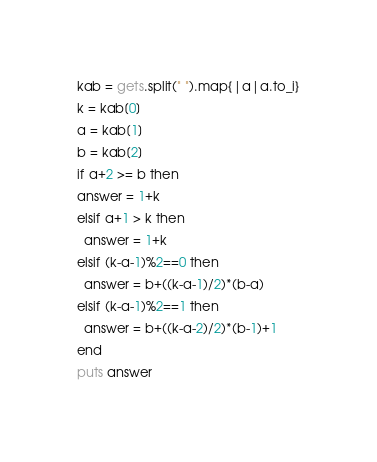<code> <loc_0><loc_0><loc_500><loc_500><_Ruby_>kab = gets.split(" ").map{|a|a.to_i}
k = kab[0]
a = kab[1]
b = kab[2]
if a+2 >= b then
answer = 1+k
elsif a+1 > k then
  answer = 1+k
elsif (k-a-1)%2==0 then
  answer = b+((k-a-1)/2)*(b-a)
elsif (k-a-1)%2==1 then
  answer = b+((k-a-2)/2)*(b-1)+1
end
puts answer
</code> 